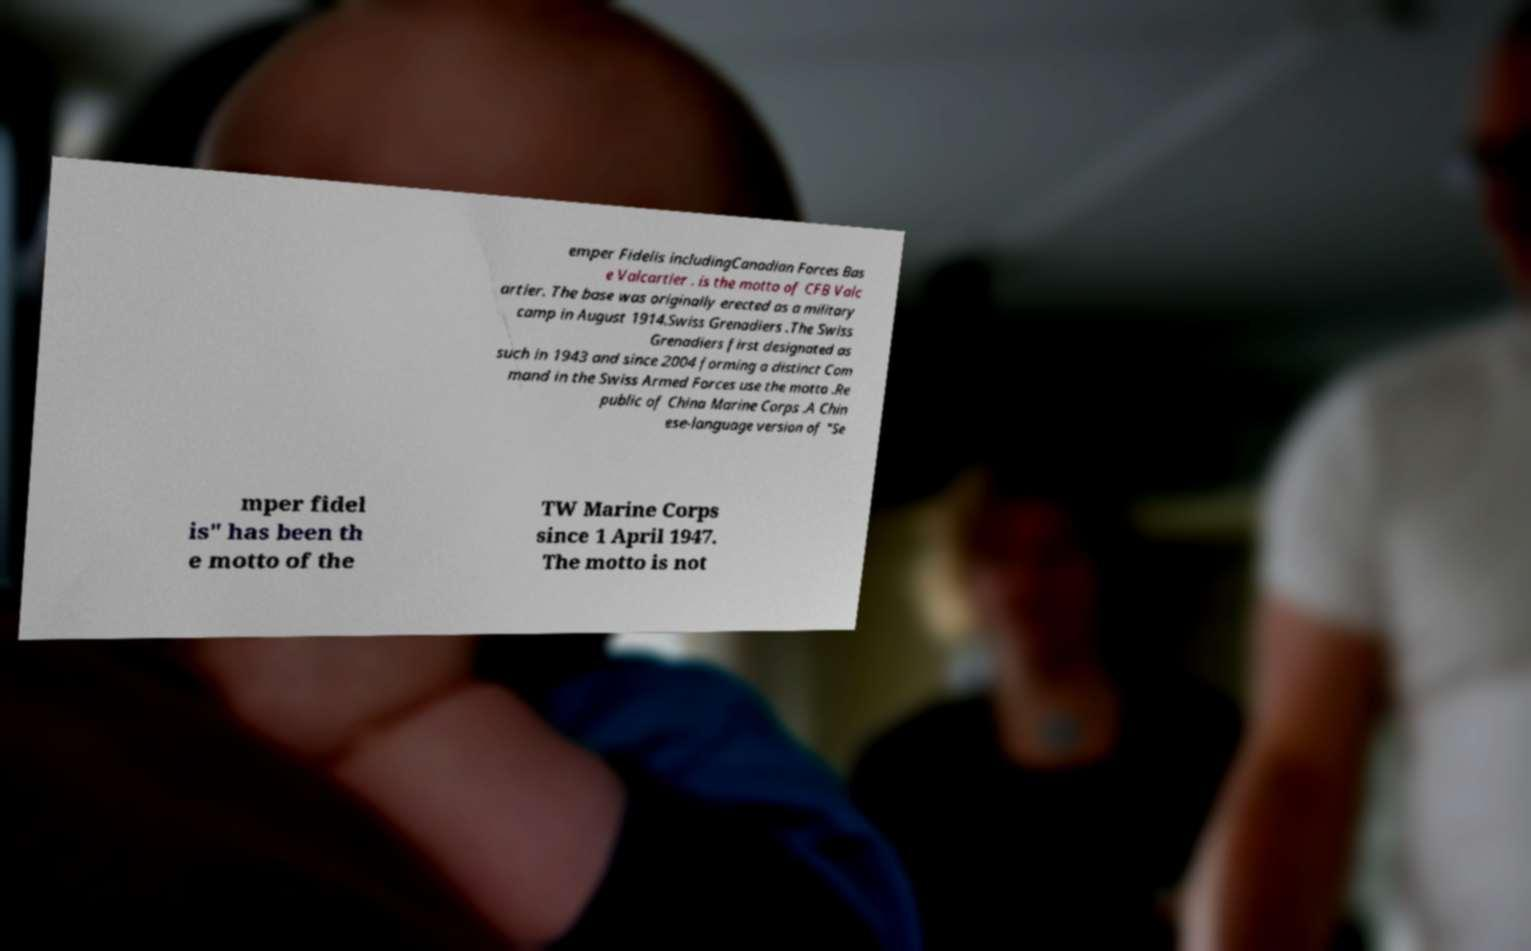I need the written content from this picture converted into text. Can you do that? emper Fidelis includingCanadian Forces Bas e Valcartier . is the motto of CFB Valc artier. The base was originally erected as a military camp in August 1914.Swiss Grenadiers .The Swiss Grenadiers first designated as such in 1943 and since 2004 forming a distinct Com mand in the Swiss Armed Forces use the motto .Re public of China Marine Corps .A Chin ese-language version of "Se mper fidel is" has been th e motto of the TW Marine Corps since 1 April 1947. The motto is not 